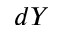<formula> <loc_0><loc_0><loc_500><loc_500>d Y</formula> 